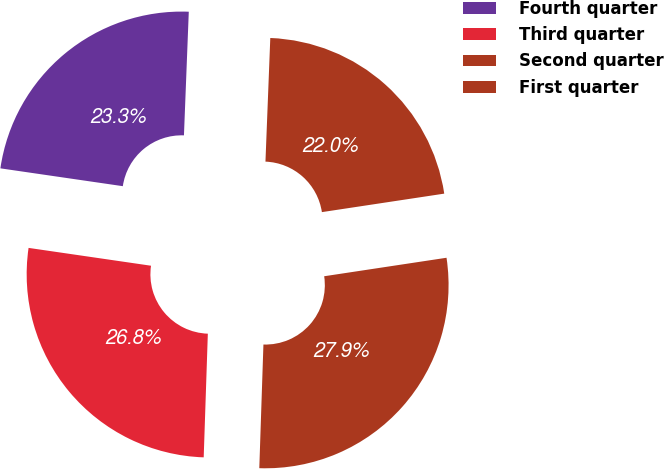Convert chart. <chart><loc_0><loc_0><loc_500><loc_500><pie_chart><fcel>Fourth quarter<fcel>Third quarter<fcel>Second quarter<fcel>First quarter<nl><fcel>23.32%<fcel>26.77%<fcel>27.92%<fcel>21.99%<nl></chart> 